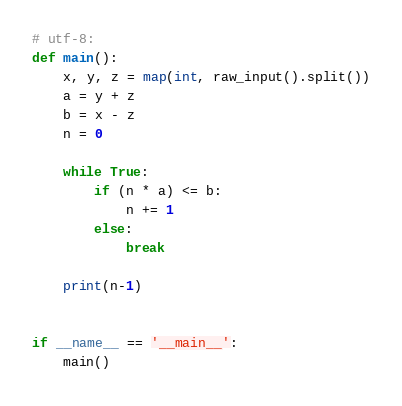<code> <loc_0><loc_0><loc_500><loc_500><_Python_># utf-8:
def main():
    x, y, z = map(int, raw_input().split())
    a = y + z
    b = x - z
    n = 0

    while True:
        if (n * a) <= b:
            n += 1
        else:
            break

    print(n-1)


if __name__ == '__main__':
    main()
</code> 